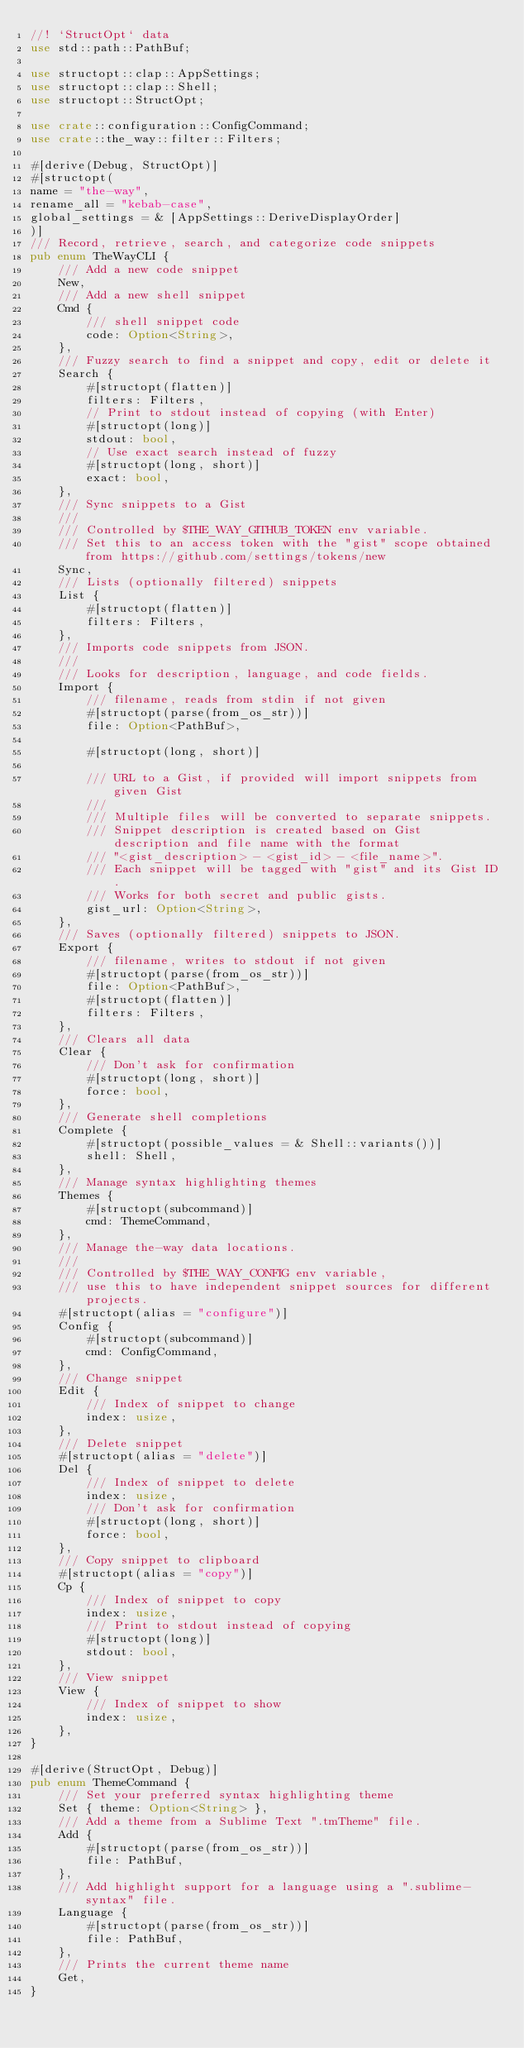<code> <loc_0><loc_0><loc_500><loc_500><_Rust_>//! `StructOpt` data
use std::path::PathBuf;

use structopt::clap::AppSettings;
use structopt::clap::Shell;
use structopt::StructOpt;

use crate::configuration::ConfigCommand;
use crate::the_way::filter::Filters;

#[derive(Debug, StructOpt)]
#[structopt(
name = "the-way",
rename_all = "kebab-case",
global_settings = & [AppSettings::DeriveDisplayOrder]
)]
/// Record, retrieve, search, and categorize code snippets
pub enum TheWayCLI {
    /// Add a new code snippet
    New,
    /// Add a new shell snippet
    Cmd {
        /// shell snippet code
        code: Option<String>,
    },
    /// Fuzzy search to find a snippet and copy, edit or delete it
    Search {
        #[structopt(flatten)]
        filters: Filters,
        // Print to stdout instead of copying (with Enter)
        #[structopt(long)]
        stdout: bool,
        // Use exact search instead of fuzzy
        #[structopt(long, short)]
        exact: bool,
    },
    /// Sync snippets to a Gist
    ///
    /// Controlled by $THE_WAY_GITHUB_TOKEN env variable.
    /// Set this to an access token with the "gist" scope obtained from https://github.com/settings/tokens/new
    Sync,
    /// Lists (optionally filtered) snippets
    List {
        #[structopt(flatten)]
        filters: Filters,
    },
    /// Imports code snippets from JSON.
    ///
    /// Looks for description, language, and code fields.
    Import {
        /// filename, reads from stdin if not given
        #[structopt(parse(from_os_str))]
        file: Option<PathBuf>,

        #[structopt(long, short)]

        /// URL to a Gist, if provided will import snippets from given Gist
        ///
        /// Multiple files will be converted to separate snippets.
        /// Snippet description is created based on Gist description and file name with the format
        /// "<gist_description> - <gist_id> - <file_name>".
        /// Each snippet will be tagged with "gist" and its Gist ID.
        /// Works for both secret and public gists.
        gist_url: Option<String>,
    },
    /// Saves (optionally filtered) snippets to JSON.
    Export {
        /// filename, writes to stdout if not given
        #[structopt(parse(from_os_str))]
        file: Option<PathBuf>,
        #[structopt(flatten)]
        filters: Filters,
    },
    /// Clears all data
    Clear {
        /// Don't ask for confirmation
        #[structopt(long, short)]
        force: bool,
    },
    /// Generate shell completions
    Complete {
        #[structopt(possible_values = & Shell::variants())]
        shell: Shell,
    },
    /// Manage syntax highlighting themes
    Themes {
        #[structopt(subcommand)]
        cmd: ThemeCommand,
    },
    /// Manage the-way data locations.
    ///
    /// Controlled by $THE_WAY_CONFIG env variable,
    /// use this to have independent snippet sources for different projects.
    #[structopt(alias = "configure")]
    Config {
        #[structopt(subcommand)]
        cmd: ConfigCommand,
    },
    /// Change snippet
    Edit {
        /// Index of snippet to change
        index: usize,
    },
    /// Delete snippet
    #[structopt(alias = "delete")]
    Del {
        /// Index of snippet to delete
        index: usize,
        /// Don't ask for confirmation
        #[structopt(long, short)]
        force: bool,
    },
    /// Copy snippet to clipboard
    #[structopt(alias = "copy")]
    Cp {
        /// Index of snippet to copy
        index: usize,
        /// Print to stdout instead of copying
        #[structopt(long)]
        stdout: bool,
    },
    /// View snippet
    View {
        /// Index of snippet to show
        index: usize,
    },
}

#[derive(StructOpt, Debug)]
pub enum ThemeCommand {
    /// Set your preferred syntax highlighting theme
    Set { theme: Option<String> },
    /// Add a theme from a Sublime Text ".tmTheme" file.
    Add {
        #[structopt(parse(from_os_str))]
        file: PathBuf,
    },
    /// Add highlight support for a language using a ".sublime-syntax" file.
    Language {
        #[structopt(parse(from_os_str))]
        file: PathBuf,
    },
    /// Prints the current theme name
    Get,
}
</code> 